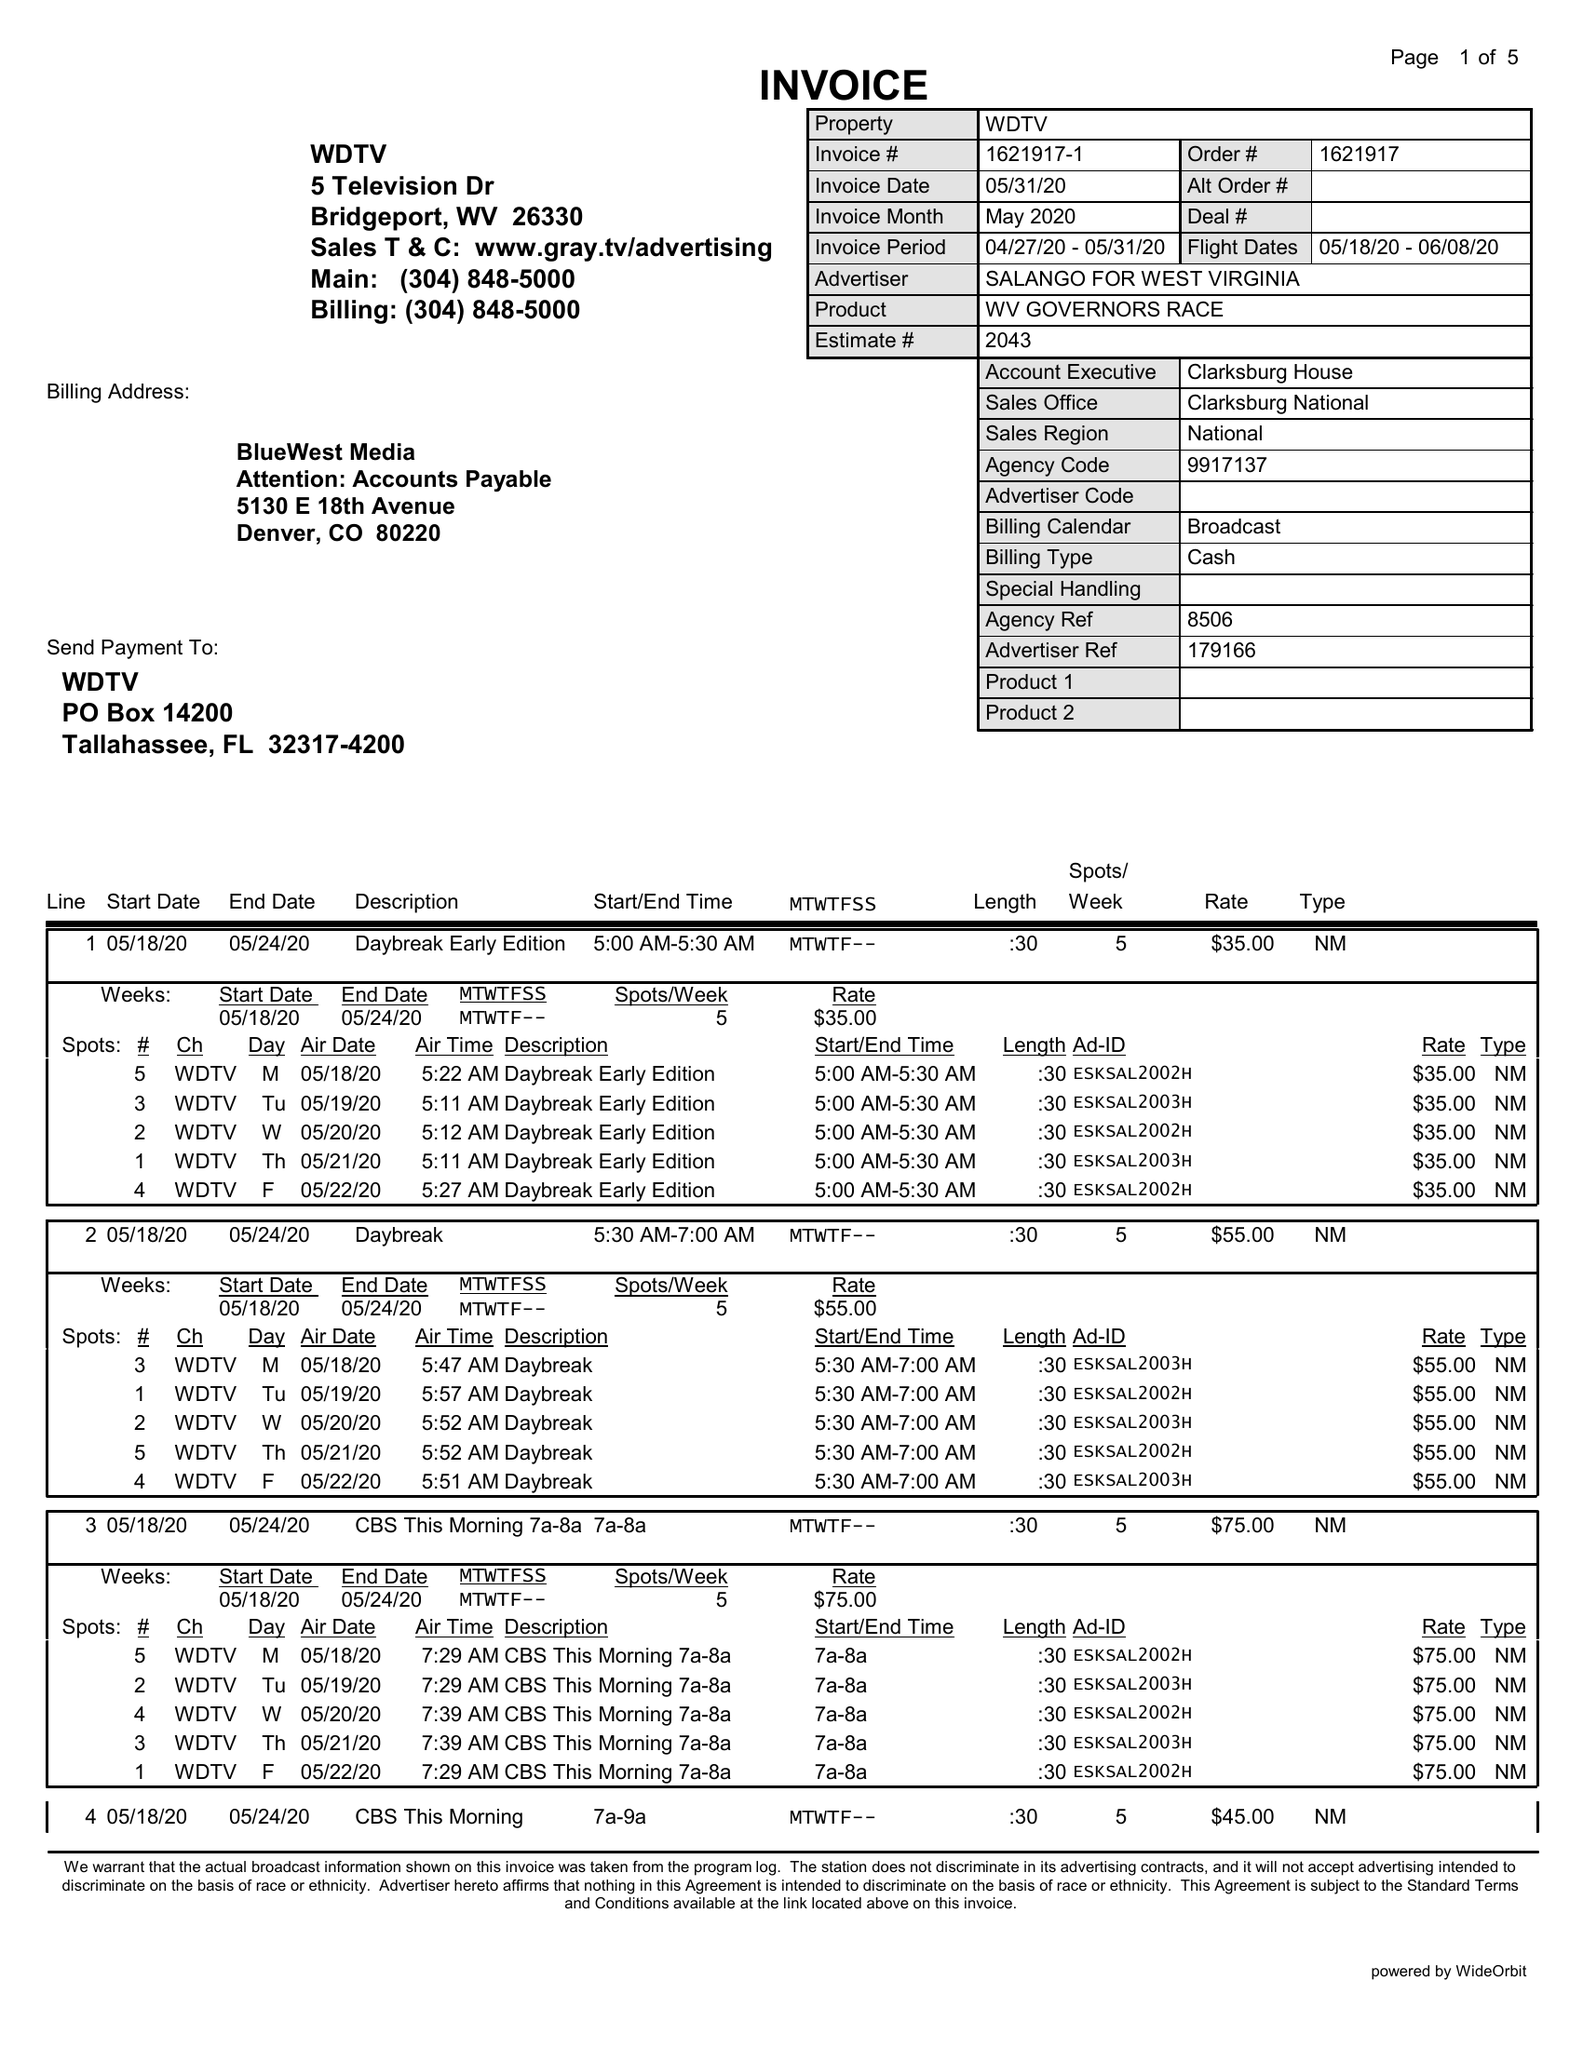What is the value for the advertiser?
Answer the question using a single word or phrase. SALANGO FOR WEST VIRGINIA 